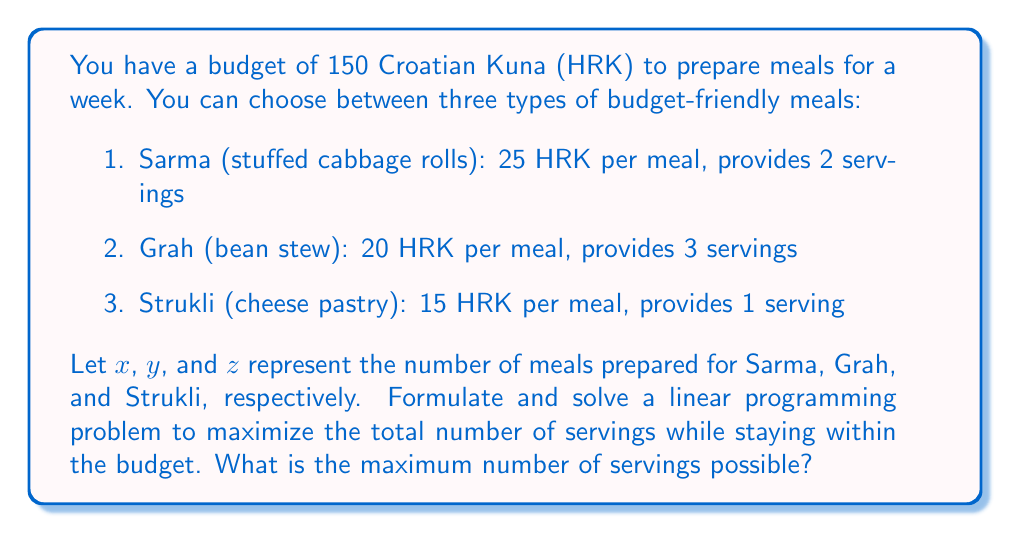Help me with this question. To solve this problem, we need to set up a linear programming model and then solve it.

1. Objective function:
   We want to maximize the total number of servings:
   $$\text{Maximize } 2x + 3y + z$$

2. Constraints:
   Budget constraint: $$25x + 20y + 15z \leq 150$$
   Non-negativity constraints: $$x, y, z \geq 0$$

3. Solving the linear programming problem:
   We can use the simplex method or graphical method to solve this. For simplicity, let's use the graphical method.

   a) First, we plot the budget constraint:
      $$25x + 20y + 15z = 150$$

   b) We then consider the extreme points:
      (0, 0, 10), (0, 7.5, 0), (6, 0, 0)

   c) Evaluate the objective function at these points:
      (0, 0, 10): 2(0) + 3(0) + 1(10) = 10 servings
      (0, 7.5, 0): 2(0) + 3(7.5) + 1(0) = 22.5 servings
      (6, 0, 0): 2(6) + 3(0) + 1(0) = 12 servings

   d) The maximum value occurs at (0, 7.5, 0), but we need integer solutions.

   e) Checking nearby integer points:
      (0, 7, 0): 2(0) + 3(7) + 1(0) = 21 servings (140 HRK)
      (0, 7, 1): 2(0) + 3(7) + 1(1) = 22 servings (155 HRK, over budget)

Therefore, the optimal integer solution is to prepare 7 meals of Grah (bean stew).
Answer: The maximum number of servings possible within the budget is 21, achieved by preparing 7 meals of Grah (bean stew). 